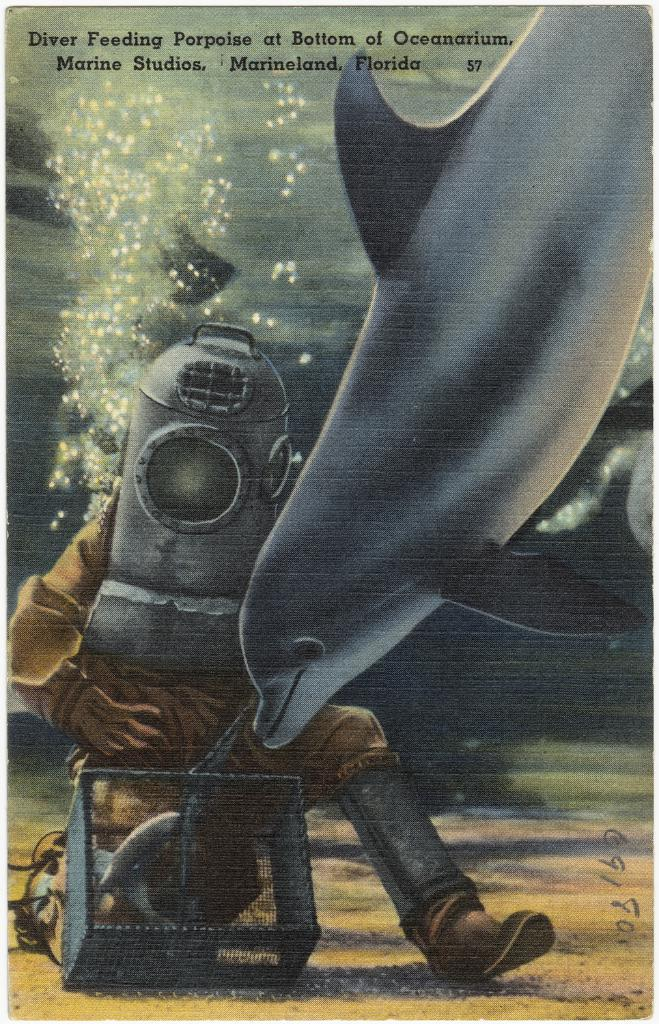What is the main subject of the image? There is a fish in the image. Is there a person present in the image? Yes, there is a person in the image. What else can be seen in the image besides the fish and person? There are objects and water visible in the image. Are there any words or letters in the image? Yes, there is text in the image. How can you tell that the image might be edited? The image appears to be an edited photo. What type of grape is being used to make the jam in the image? There is no grape or jam present in the image; it features a fish, a person, objects, water, and text. 